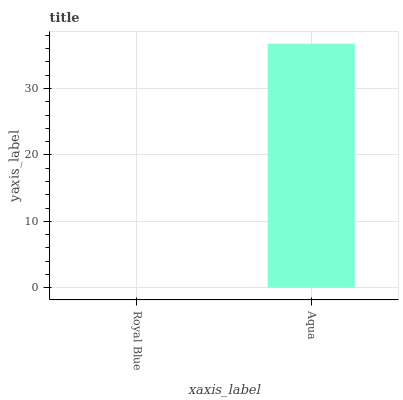Is Aqua the minimum?
Answer yes or no. No. Is Aqua greater than Royal Blue?
Answer yes or no. Yes. Is Royal Blue less than Aqua?
Answer yes or no. Yes. Is Royal Blue greater than Aqua?
Answer yes or no. No. Is Aqua less than Royal Blue?
Answer yes or no. No. Is Aqua the high median?
Answer yes or no. Yes. Is Royal Blue the low median?
Answer yes or no. Yes. Is Royal Blue the high median?
Answer yes or no. No. Is Aqua the low median?
Answer yes or no. No. 